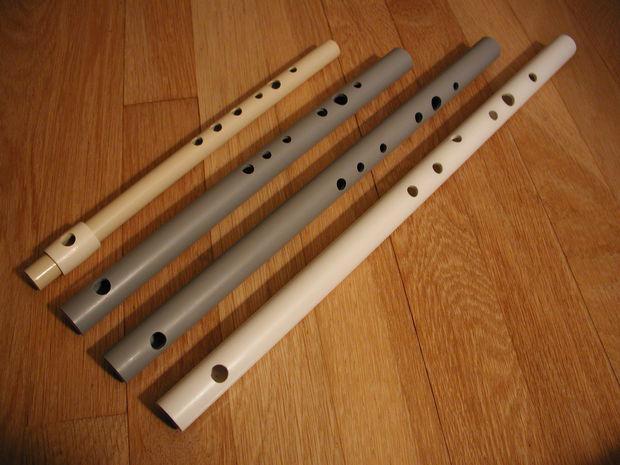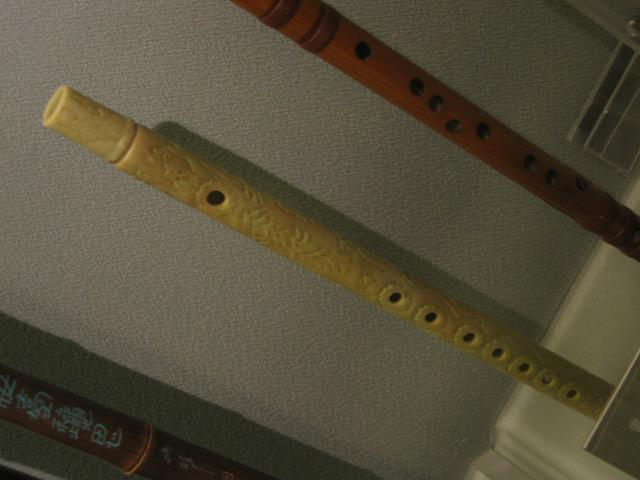The first image is the image on the left, the second image is the image on the right. For the images shown, is this caption "In the right image, the instruments are displayed horizontally." true? Answer yes or no. No. The first image is the image on the left, the second image is the image on the right. Analyze the images presented: Is the assertion "In the image to the right, three parts of a flute are held horizontally." valid? Answer yes or no. No. 